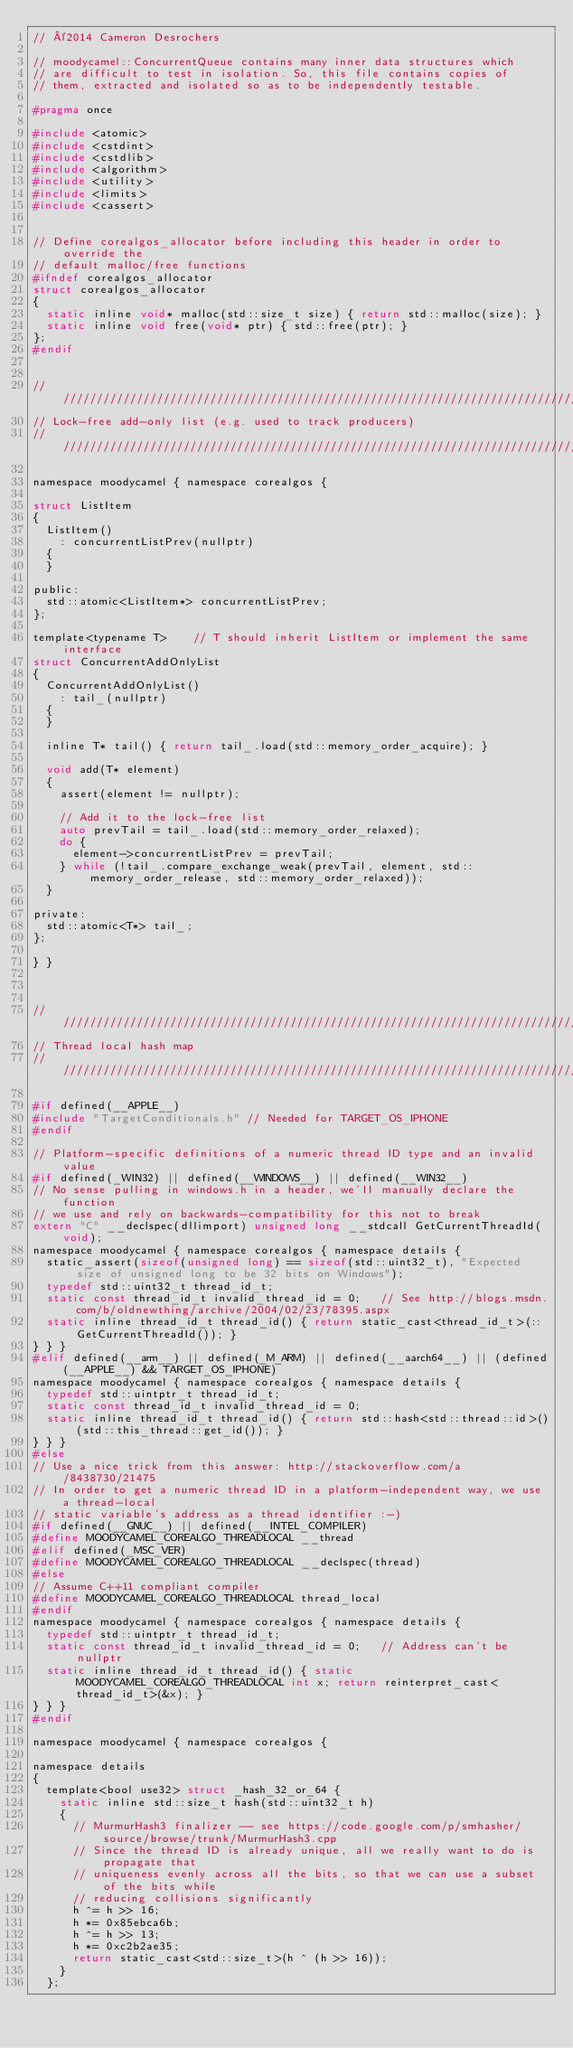<code> <loc_0><loc_0><loc_500><loc_500><_C_>// ©2014 Cameron Desrochers

// moodycamel::ConcurrentQueue contains many inner data structures which
// are difficult to test in isolation. So, this file contains copies of
// them, extracted and isolated so as to be independently testable.

#pragma once

#include <atomic>
#include <cstdint>
#include <cstdlib>
#include <algorithm>
#include <utility>
#include <limits>
#include <cassert>


// Define corealgos_allocator before including this header in order to override the
// default malloc/free functions
#ifndef corealgos_allocator
struct corealgos_allocator
{
	static inline void* malloc(std::size_t size) { return std::malloc(size); }
	static inline void free(void* ptr) { std::free(ptr); }
};
#endif


////////////////////////////////////////////////////////////////////////////////
// Lock-free add-only list (e.g. used to track producers)
////////////////////////////////////////////////////////////////////////////////

namespace moodycamel { namespace corealgos {

struct ListItem
{
	ListItem()
		: concurrentListPrev(nullptr)
	{
	}
	
public:
	std::atomic<ListItem*> concurrentListPrev;
};

template<typename T>		// T should inherit ListItem or implement the same interface
struct ConcurrentAddOnlyList
{
	ConcurrentAddOnlyList()
		: tail_(nullptr)
	{
	}
	
	inline T* tail() { return tail_.load(std::memory_order_acquire); }
	
	void add(T* element)
	{
		assert(element != nullptr);
		
		// Add it to the lock-free list
		auto prevTail = tail_.load(std::memory_order_relaxed);
		do {
			element->concurrentListPrev = prevTail;
		} while (!tail_.compare_exchange_weak(prevTail, element, std::memory_order_release, std::memory_order_relaxed));
	}
	
private:
	std::atomic<T*> tail_;
};

} }



////////////////////////////////////////////////////////////////////////////////
// Thread local hash map
////////////////////////////////////////////////////////////////////////////////

#if defined(__APPLE__)
#include "TargetConditionals.h" // Needed for TARGET_OS_IPHONE
#endif

// Platform-specific definitions of a numeric thread ID type and an invalid value
#if defined(_WIN32) || defined(__WINDOWS__) || defined(__WIN32__)
// No sense pulling in windows.h in a header, we'll manually declare the function
// we use and rely on backwards-compatibility for this not to break
extern "C" __declspec(dllimport) unsigned long __stdcall GetCurrentThreadId(void);
namespace moodycamel { namespace corealgos { namespace details {
	static_assert(sizeof(unsigned long) == sizeof(std::uint32_t), "Expected size of unsigned long to be 32 bits on Windows");
	typedef std::uint32_t thread_id_t;
	static const thread_id_t invalid_thread_id = 0;		// See http://blogs.msdn.com/b/oldnewthing/archive/2004/02/23/78395.aspx
	static inline thread_id_t thread_id() { return static_cast<thread_id_t>(::GetCurrentThreadId()); }
} } }
#elif defined(__arm__) || defined(_M_ARM) || defined(__aarch64__) || (defined(__APPLE__) && TARGET_OS_IPHONE)
namespace moodycamel { namespace corealgos { namespace details {
	typedef std::uintptr_t thread_id_t;
	static const thread_id_t invalid_thread_id = 0;
	static inline thread_id_t thread_id() { return std::hash<std::thread::id>()(std::this_thread::get_id()); }
} } }
#else
// Use a nice trick from this answer: http://stackoverflow.com/a/8438730/21475
// In order to get a numeric thread ID in a platform-independent way, we use a thread-local
// static variable's address as a thread identifier :-)
#if defined(__GNUC__) || defined(__INTEL_COMPILER)
#define MOODYCAMEL_COREALGO_THREADLOCAL __thread
#elif defined(_MSC_VER)
#define MOODYCAMEL_COREALGO_THREADLOCAL __declspec(thread)
#else
// Assume C++11 compliant compiler
#define MOODYCAMEL_COREALGO_THREADLOCAL thread_local
#endif
namespace moodycamel { namespace corealgos { namespace details {
	typedef std::uintptr_t thread_id_t;
	static const thread_id_t invalid_thread_id = 0;		// Address can't be nullptr
	static inline thread_id_t thread_id() { static MOODYCAMEL_COREALGO_THREADLOCAL int x; return reinterpret_cast<thread_id_t>(&x); }
} } }
#endif

namespace moodycamel { namespace corealgos {

namespace details
{
	template<bool use32> struct _hash_32_or_64 {
		static inline std::size_t hash(std::uint32_t h)
		{
			// MurmurHash3 finalizer -- see https://code.google.com/p/smhasher/source/browse/trunk/MurmurHash3.cpp
			// Since the thread ID is already unique, all we really want to do is propagate that
			// uniqueness evenly across all the bits, so that we can use a subset of the bits while
			// reducing collisions significantly
			h ^= h >> 16;
			h *= 0x85ebca6b;
			h ^= h >> 13;
			h *= 0xc2b2ae35;
			return static_cast<std::size_t>(h ^ (h >> 16));
		}
	};</code> 